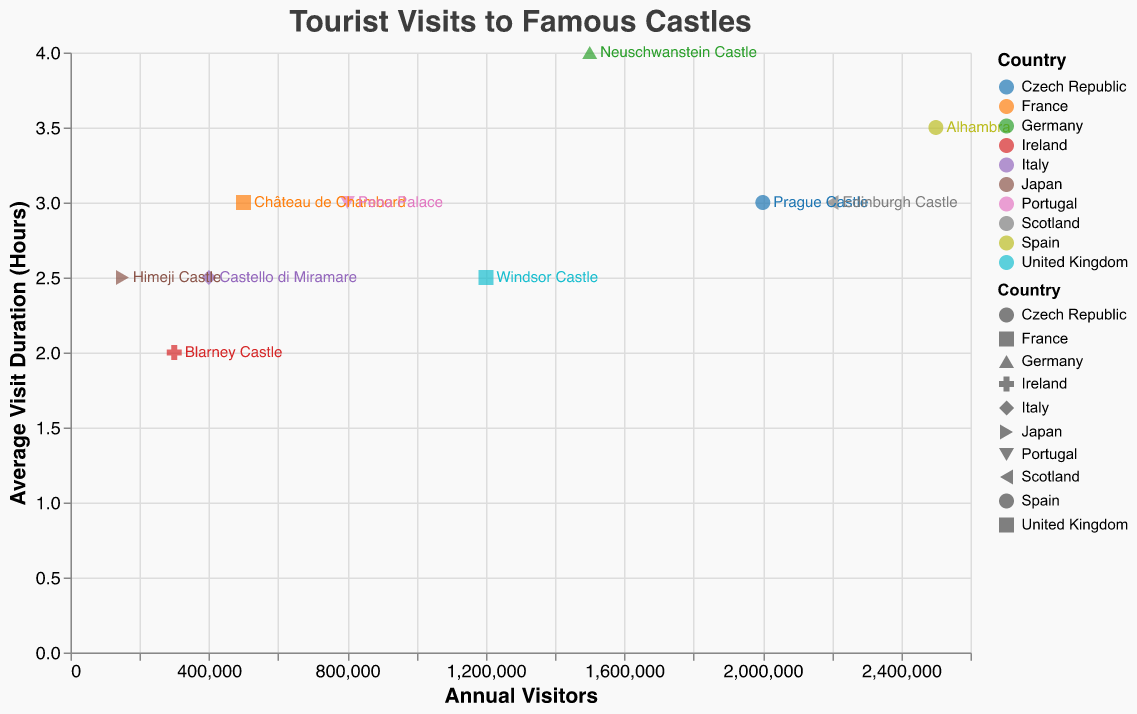How many castles are in the dataset? Count the number of data points in the dataset. There are 10 castles listed in the data, each corresponding to a different data point in the plot.
Answer: 10 Which castle has the highest frequency of visits per year? Find the data point with the highest value on the x-axis (Annual Visitors). Alhambra in Spain has 2,500,000 annual visitors, making it the highest.
Answer: Alhambra in Spain Which country has castles with the shortest and longest average visit durations? Compare the y-axis (Average Visit Duration) values for each country. Blarney Castle in Ireland has the shortest duration at 2 hours, and Neuschwanstein Castle in Germany has the longest at 4 hours.
Answer: Ireland and Germany Which castle has a higher frequency of visits per year, Edinburgh Castle or Windsor Castle? Compare the x-axis (Annual Visitors) values of Edinburgh Castle and Windsor Castle. Edinburgh Castle has 2,200,000 visits, while Windsor Castle has 1,200,000.
Answer: Edinburgh Castle What is the average visit duration for castles in the United Kingdom? Calculate the average of the y-axis (Average Visit Duration) values for Windsor Castle. Windsor Castle has an average visit duration of 2.5 hours.
Answer: 2.5 hours Between Prague Castle and Château de Chambord, which has more annual visitors, and by how much? Check the x-axis values for both castles. Prague Castle has 2,000,000 visitors, and Château de Chambord has 500,000. The difference is 2,000,000 - 500,000 = 1,500,000.
Answer: Prague Castle by 1,500,000 Which castle in Asia has the highest frequency of visits per year? Identify the castle in Asia and check its x-axis (Annual Visitors) value. Himeji Castle in Japan is the only Asian castle in the dataset with 150,000 visits per year.
Answer: Himeji Castle What is the combined average visit duration for the castles in France and Portugal? Sum the y-axis values for Château de Chambord (3 hours) and Pena Palace (3 hours), then divide by 2. The combined average is (3 + 3) / 2 = 3 hours.
Answer: 3 hours Which castle has the highest visit frequency among the Central European countries listed? Look at the data points for Germany, Czech Republic, and Austria, and compare x-axis values. Prague Castle in the Czech Republic has 2,000,000 visits, the highest among Central European castles listed.
Answer: Prague Castle in the Czech Republic 